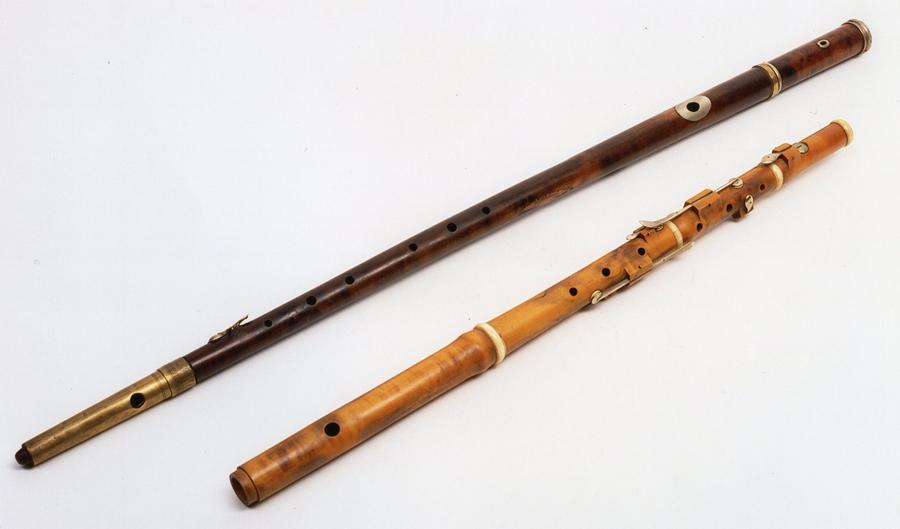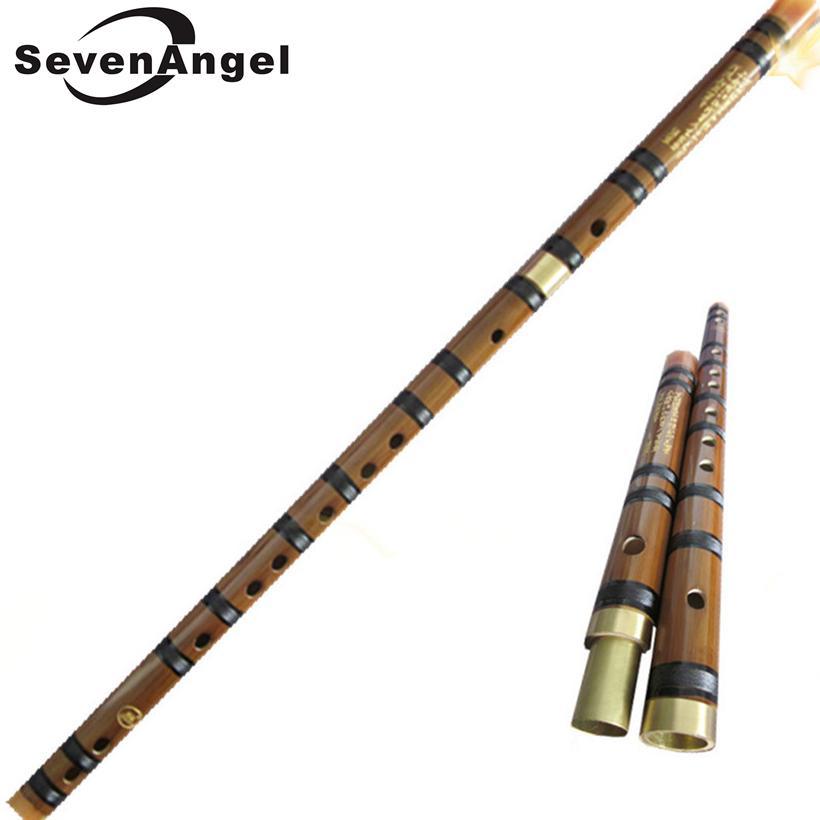The first image is the image on the left, the second image is the image on the right. Given the left and right images, does the statement "There are two flutes in the left image." hold true? Answer yes or no. Yes. The first image is the image on the left, the second image is the image on the right. For the images shown, is this caption "The left image contains a single flute displayed at an angle, and the right image contains at least one flute displayed at an angle opposite that of the flute on the left." true? Answer yes or no. No. 